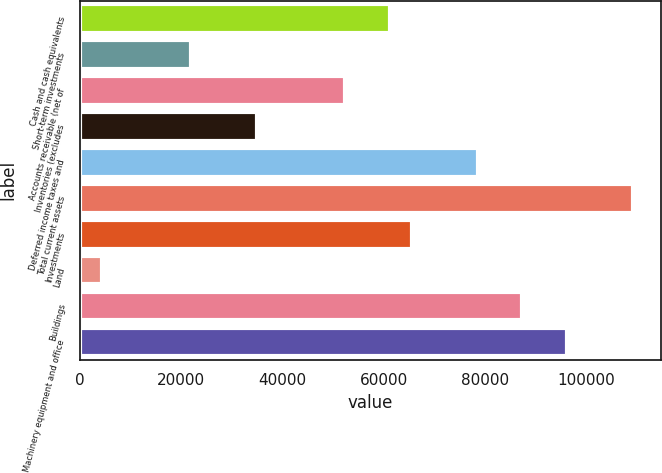Convert chart to OTSL. <chart><loc_0><loc_0><loc_500><loc_500><bar_chart><fcel>Cash and cash equivalents<fcel>Short-term investments<fcel>Accounts receivable (net of<fcel>Inventories (excludes<fcel>Deferred income taxes and<fcel>Total current assets<fcel>Investments<fcel>Land<fcel>Buildings<fcel>Machinery equipment and office<nl><fcel>61166.4<fcel>21864.3<fcel>52432.6<fcel>34965<fcel>78634<fcel>109202<fcel>65533.3<fcel>4396.7<fcel>87367.8<fcel>96101.6<nl></chart> 